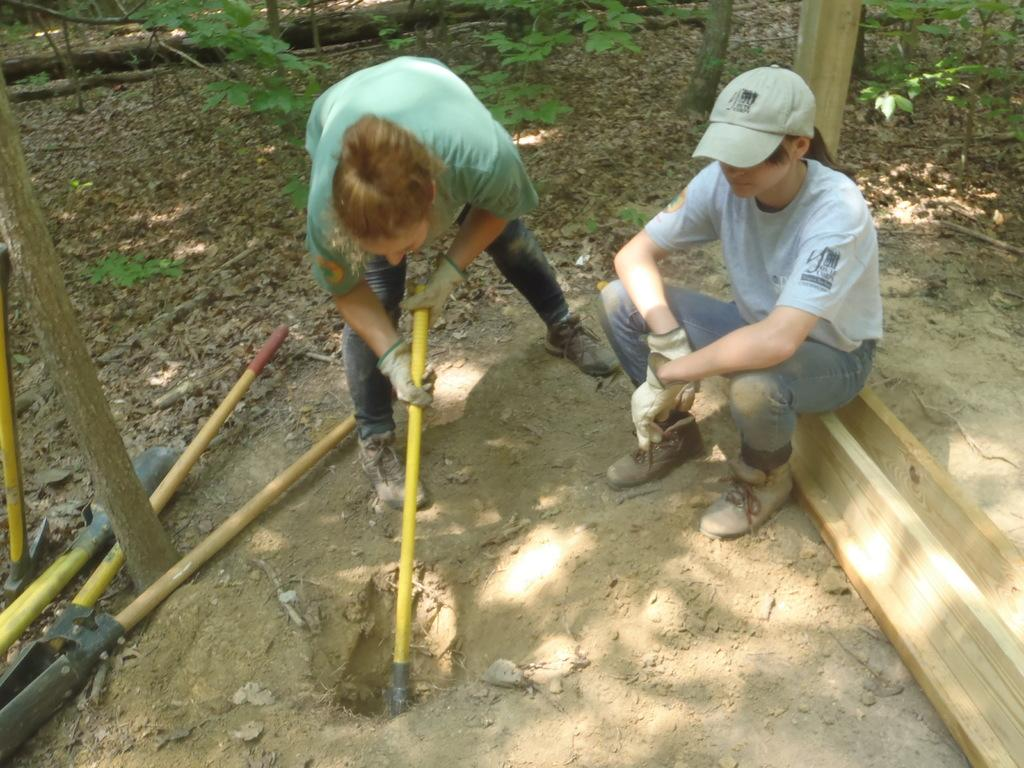How many people are in the image? There are two persons in the image. What is one person doing in the image? One person is sitting on wood. What is the other person doing in the image? The other person is digging with a tool. What can be seen in the image besides the people? There are tools visible in the image, as well as dried leaves and plants. What type of education is being discussed at the meeting in the image? There is no meeting present in the image, and therefore no discussion about education can be observed. How many dimes are visible in the image? There are no dimes present in the image. 